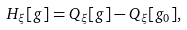Convert formula to latex. <formula><loc_0><loc_0><loc_500><loc_500>H _ { \xi } [ g ] = Q _ { \xi } [ g ] - Q _ { \xi } [ g _ { 0 } ] ,</formula> 